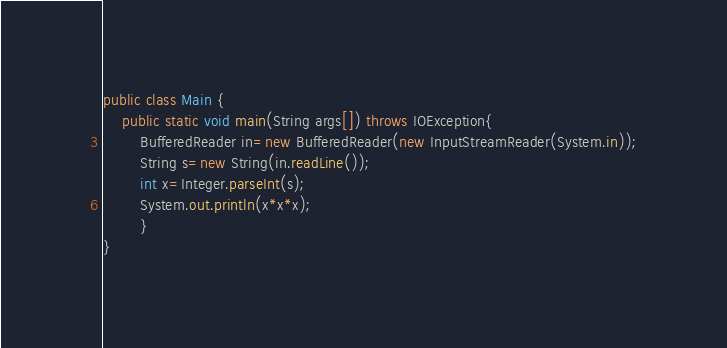<code> <loc_0><loc_0><loc_500><loc_500><_Java_>public class Main {
	public static void main(String args[]) throws IOException{
		BufferedReader in=new BufferedReader(new InputStreamReader(System.in));
		String s=new String(in.readLine());
		int x=Integer.parseInt(s);
		System.out.println(x*x*x);
		}
}</code> 